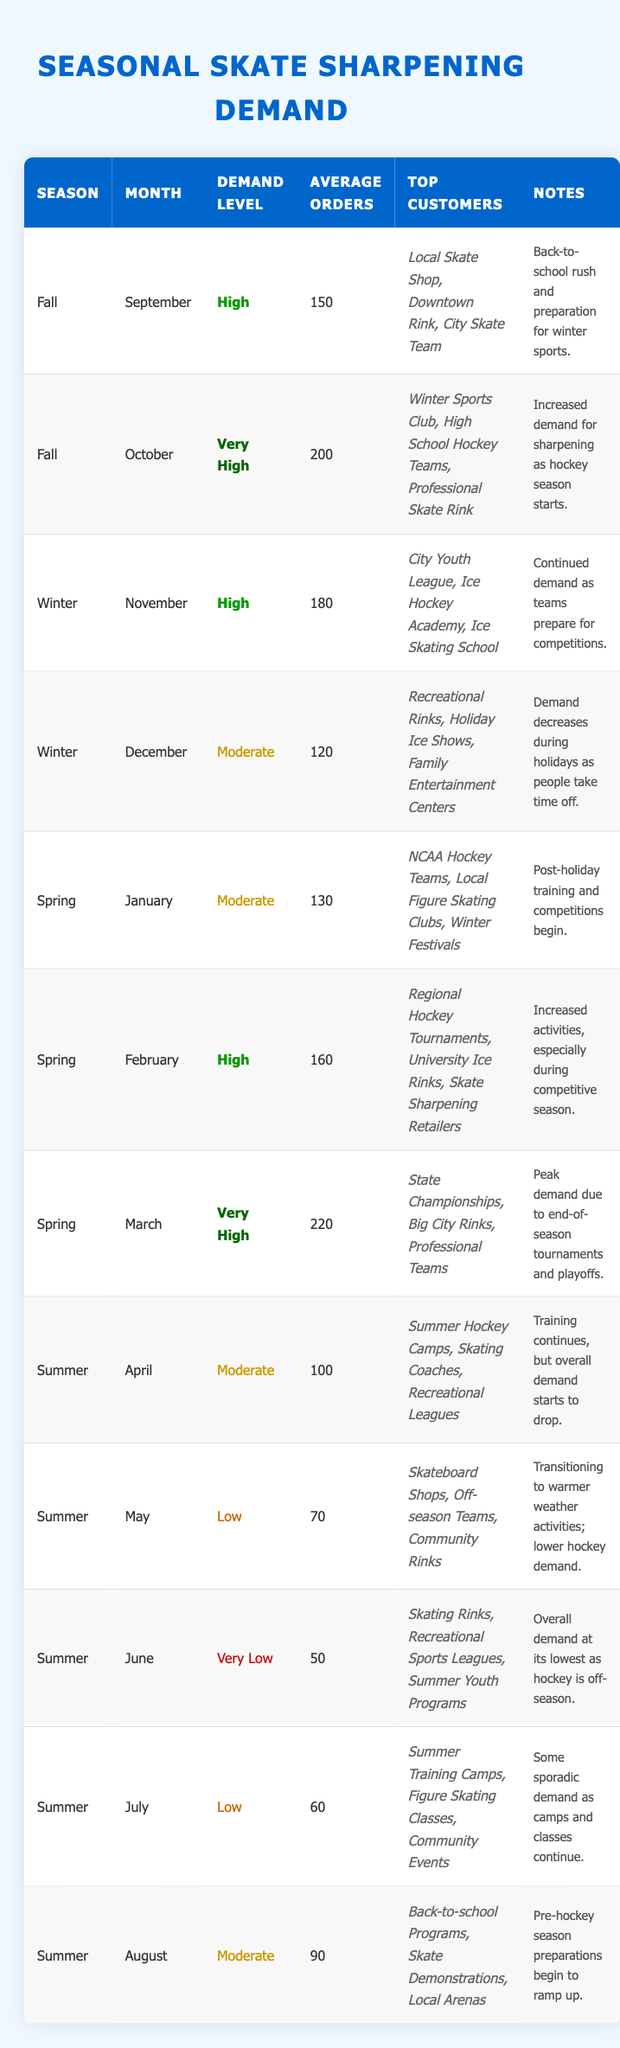What is the demand level for October? The table shows that for October, the demand level is categorized as "Very High."
Answer: Very High How many average orders were there in March? According to the table, for March, the average orders were recorded at 220.
Answer: 220 Which season has the lowest demand level and in which month does it occur? The lowest demand level is "Very Low," which occurs in June.
Answer: Summer, June What is the total average number of orders for the Winter season? To find the total average orders for Winter, we sum the average orders for November (180) and December (120): 180 + 120 = 300.
Answer: 300 Did the demand level increase from January to February? Yes, the demand level changed from "Moderate" in January to "High" in February, indicating an increase.
Answer: Yes Which month in the Summer season had the highest average orders? The month with the highest average orders in Summer is August, with 90 average orders.
Answer: August What's the average demand level across all seasons? To find the average demand level, we convert demand levels into a numeric scale: Low (1), Moderate (2), High (3), Very High (4). Calculating based on the months, the average is: (3*4 + 4*2 + 3*3 + 2*3 + 1*4 + 2*3 + 1*3 + 3*2) / 12 = 2.58, which categorically rounds around Moderate.
Answer: Moderate How many top customers are listed for April? The table shows that there are three top customers listed for April.
Answer: 3 What demand level is observed in September? The demand level in September is categorized as "High."
Answer: High 